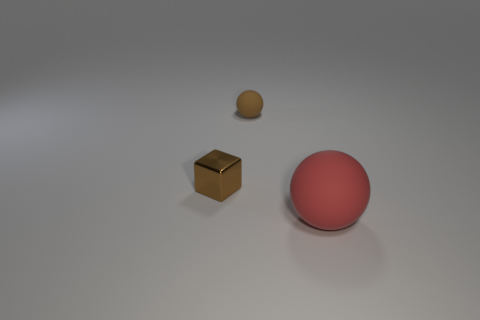Add 1 large rubber things. How many objects exist? 4 Subtract all balls. How many objects are left? 1 Add 2 big matte objects. How many big matte objects are left? 3 Add 1 cyan shiny cylinders. How many cyan shiny cylinders exist? 1 Subtract 0 brown cylinders. How many objects are left? 3 Subtract all large red objects. Subtract all matte objects. How many objects are left? 0 